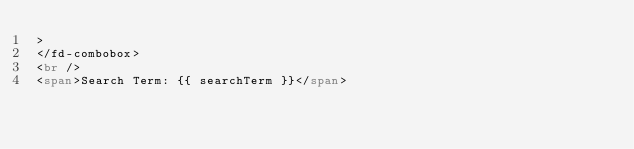<code> <loc_0><loc_0><loc_500><loc_500><_HTML_>>
</fd-combobox>
<br />
<span>Search Term: {{ searchTerm }}</span>
</code> 